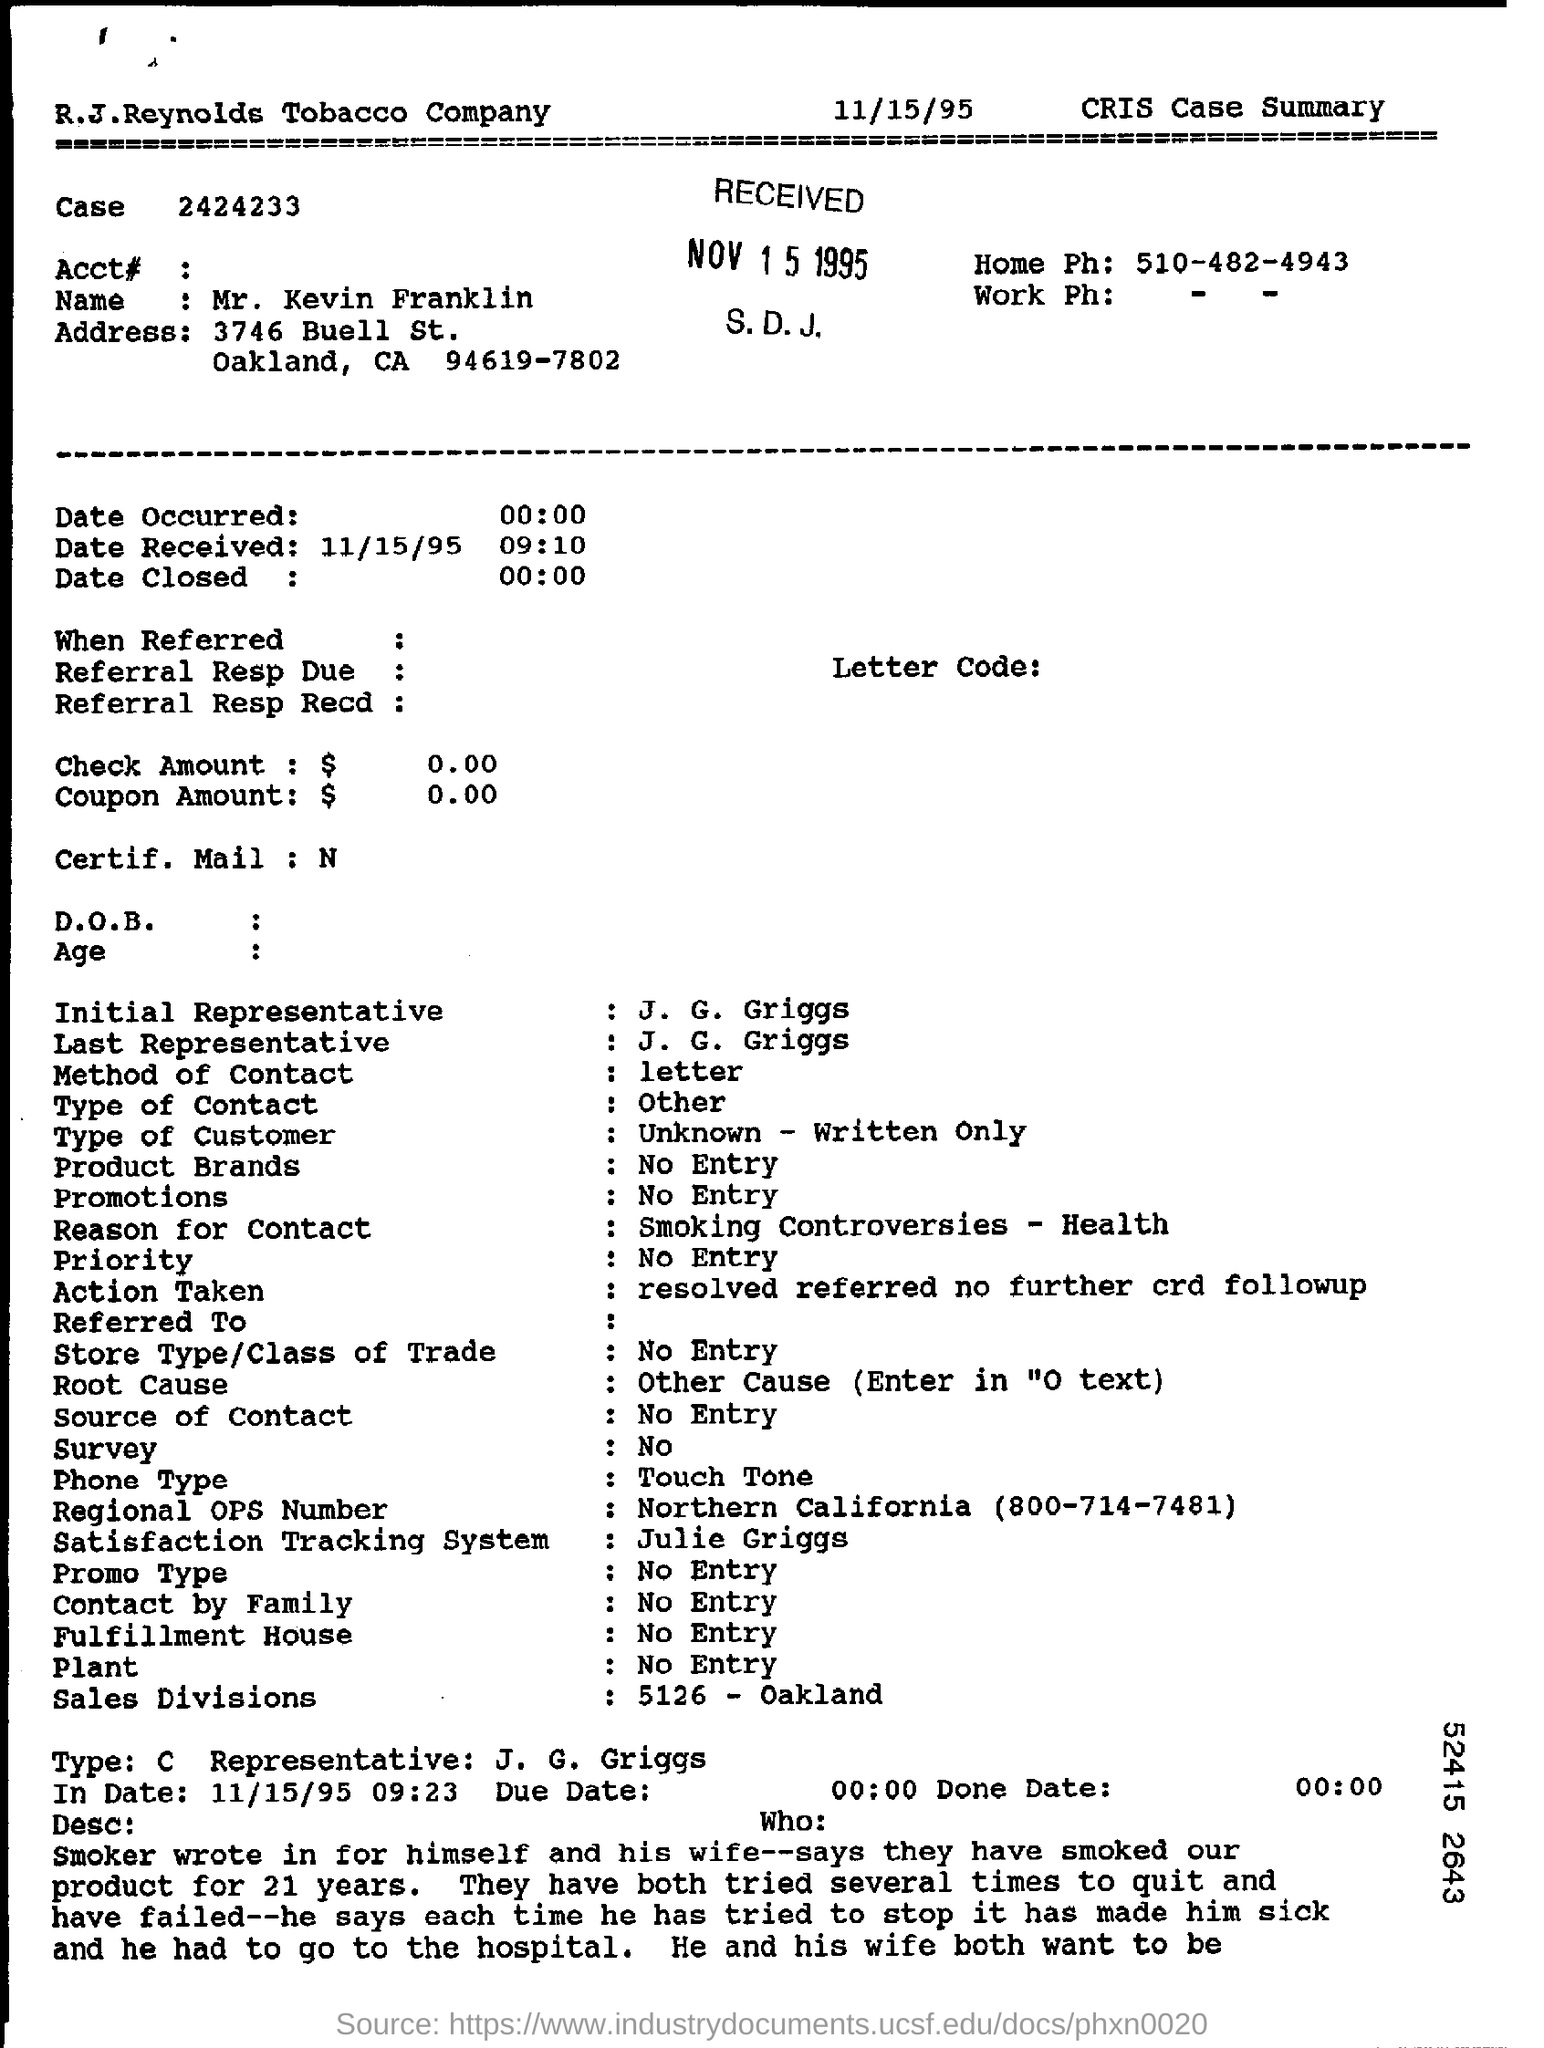Mention a couple of crucial points in this snapshot. The name in the CRIS case summary is Mr. Kevin Franklin. The Sales Division is located in Oakland at 5126. The number is 2424233...," the speaker declares. John G. Griggs is the Type C representative. The stamp date of the received item is November 15, 1995. 